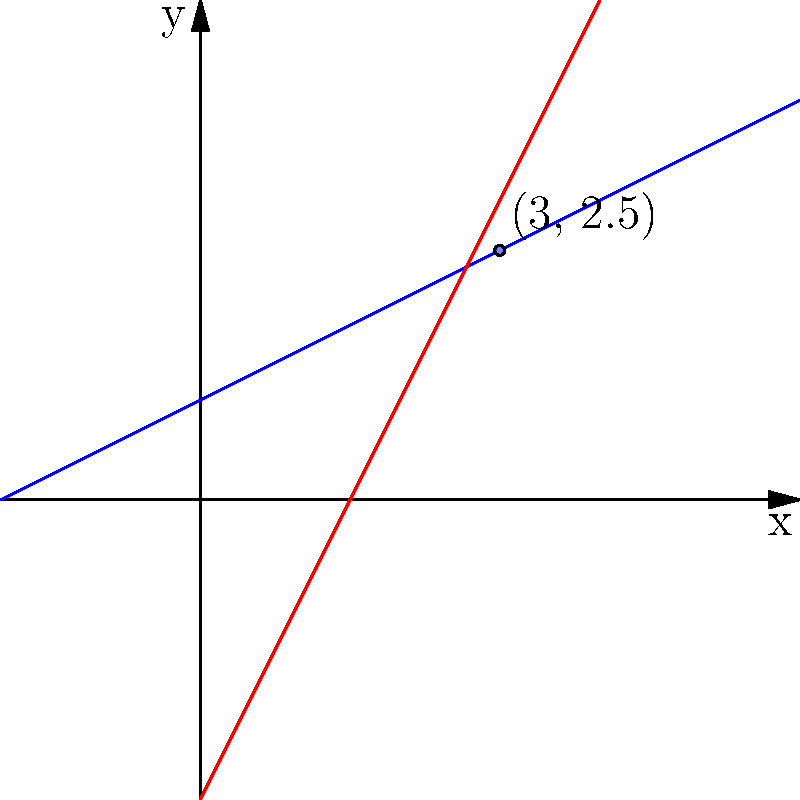In our sleek product interface design, we're considering the intersection of two design elements represented by parametric equations. Line $L_1$ is given by $x = 2t, y = t + 1$, and line $L_2$ is given by $x = t + 1, y = 2t - 1$. At what point $(x, y)$ do these lines intersect, maintaining our minimalist aesthetic? To find the intersection point, we need to solve the system of equations:

1) For $L_1$: $x = 2t, y = t + 1$
2) For $L_2$: $x = s + 1, y = 2s - 1$ (using $s$ as the parameter for $L_2$)

At the intersection point, the $x$ and $y$ coordinates must be equal for both lines:

3) $2t = s + 1$
4) $t + 1 = 2s - 1$

From equation 4:
5) $t = 2s - 2$

Substituting this into equation 3:
6) $2(2s - 2) = s + 1$
7) $4s - 4 = s + 1$
8) $3s = 5$
9) $s = \frac{5}{3}$

Substituting this back into the equations for $L_2$:
10) $x = \frac{5}{3} + 1 = \frac{8}{3} = 2\frac{2}{3} = 3$
11) $y = 2(\frac{5}{3}) - 1 = \frac{10}{3} - 1 = \frac{7}{3} = 2\frac{1}{3}$

Therefore, the intersection point is $(3, 2\frac{1}{3})$ or $(3, 2.5)$ in decimal form.
Answer: $(3, 2.5)$ 